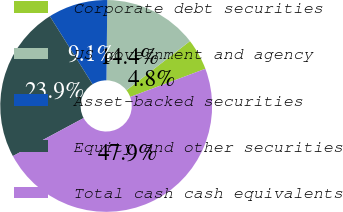<chart> <loc_0><loc_0><loc_500><loc_500><pie_chart><fcel>Corporate debt securities<fcel>US government and agency<fcel>Asset-backed securities<fcel>Equity and other securities<fcel>Total cash cash equivalents<nl><fcel>4.78%<fcel>14.35%<fcel>9.09%<fcel>23.92%<fcel>47.85%<nl></chart> 